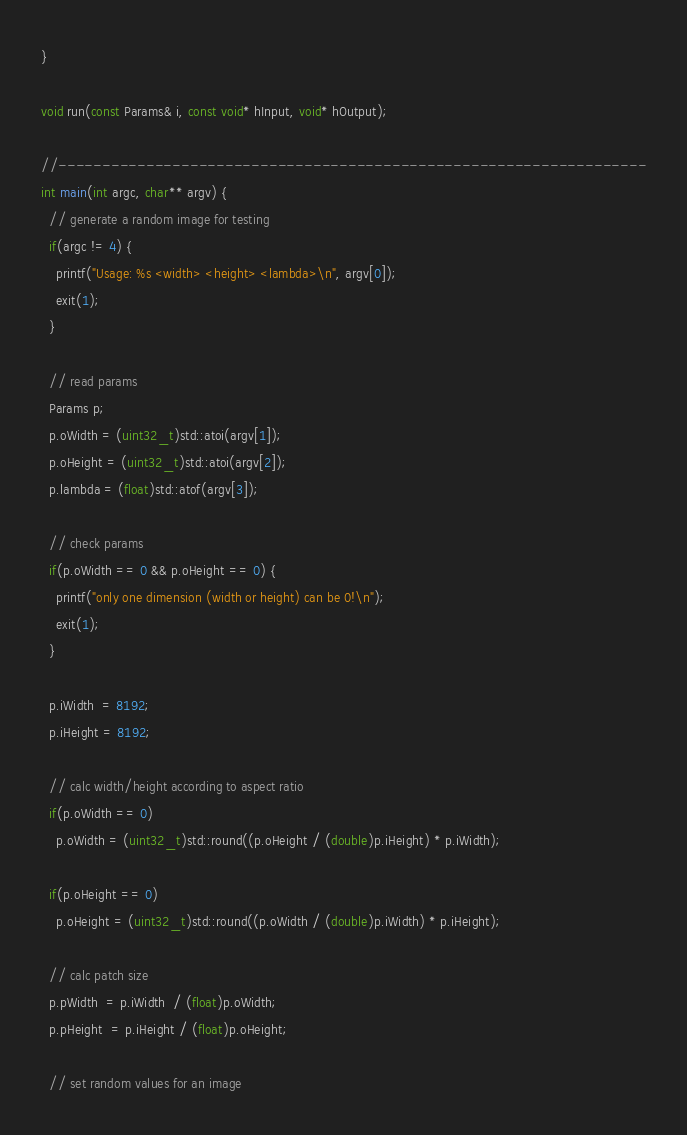<code> <loc_0><loc_0><loc_500><loc_500><_Cuda_>}

void run(const Params& i, const void* hInput, void* hOutput);

//-------------------------------------------------------------------
int main(int argc, char** argv) {
  // generate a random image for testing
  if(argc != 4) {
    printf("Usage: %s <width> <height> <lambda>\n", argv[0]);
    exit(1);
  }

  // read params
  Params p;
  p.oWidth = (uint32_t)std::atoi(argv[1]);
  p.oHeight = (uint32_t)std::atoi(argv[2]);
  p.lambda = (float)std::atof(argv[3]);

  // check params
  if(p.oWidth == 0 && p.oHeight == 0) {
    printf("only one dimension (width or height) can be 0!\n");
    exit(1);
  }

  p.iWidth  = 8192;
  p.iHeight = 8192;

  // calc width/height according to aspect ratio
  if(p.oWidth == 0)
    p.oWidth = (uint32_t)std::round((p.oHeight / (double)p.iHeight) * p.iWidth);

  if(p.oHeight == 0)
    p.oHeight = (uint32_t)std::round((p.oWidth / (double)p.iWidth) * p.iHeight);

  // calc patch size
  p.pWidth  = p.iWidth  / (float)p.oWidth;
  p.pHeight  = p.iHeight / (float)p.oHeight;

  // set random values for an image</code> 